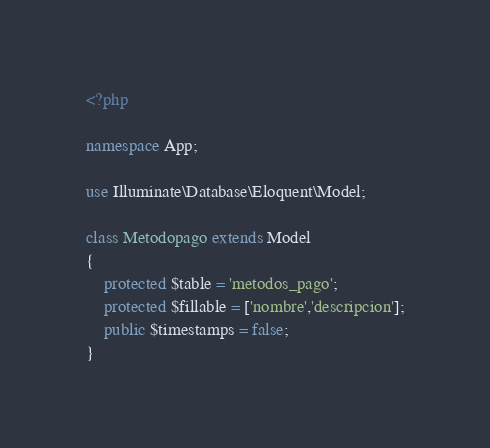Convert code to text. <code><loc_0><loc_0><loc_500><loc_500><_PHP_><?php

namespace App;

use Illuminate\Database\Eloquent\Model;

class Metodopago extends Model
{
    protected $table = 'metodos_pago';
    protected $fillable = ['nombre','descripcion'];
    public $timestamps = false;
}
</code> 